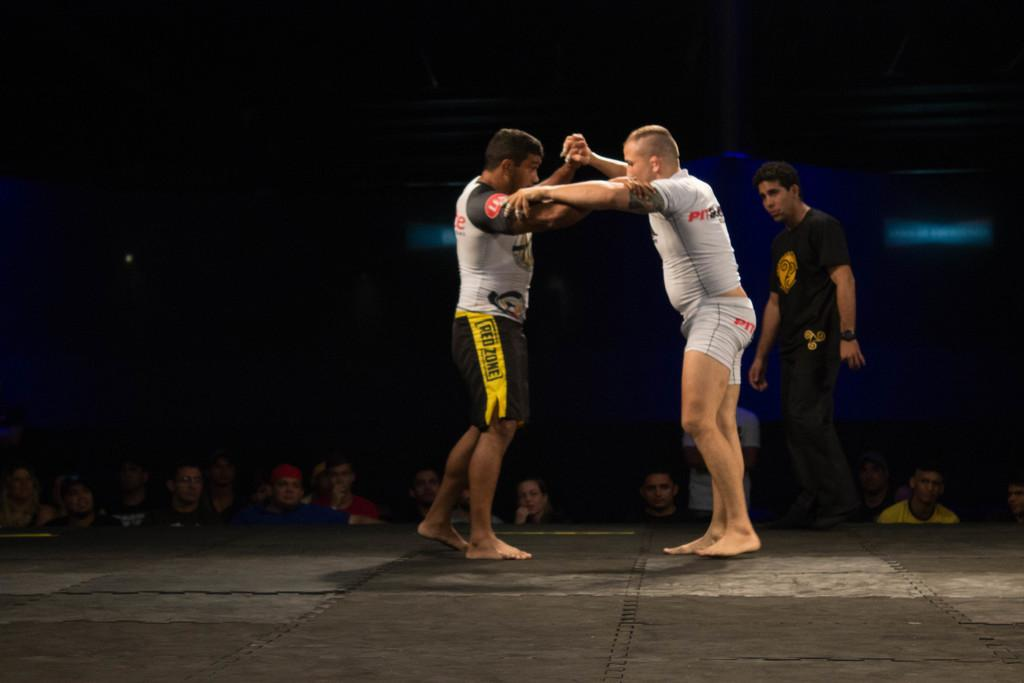What are the two people in the image doing? The two people in the image are wrestling. Is there anyone else in the image besides the two people wrestling? Yes, there is a man standing and watching the wrestling. Are there any other people in the image besides the two wrestlers and the man watching? Yes, in the background, there are people standing and watching the wrestling. What type of meal is being served to the wrestlers in the image? There is no meal being served to the wrestlers in the image; they are engaged in wrestling. 